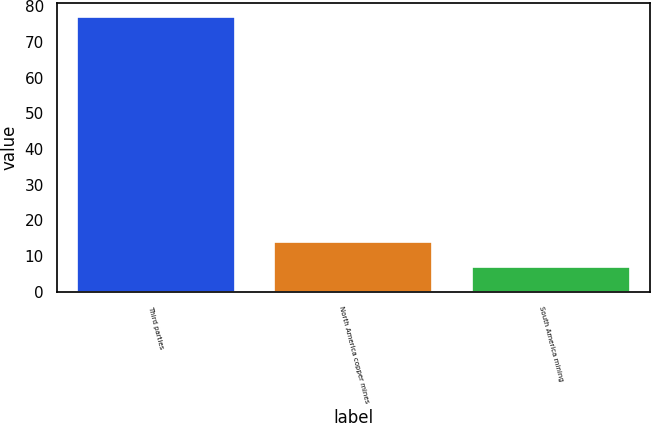Convert chart. <chart><loc_0><loc_0><loc_500><loc_500><bar_chart><fcel>Third parties<fcel>North America copper mines<fcel>South America mining<nl><fcel>77<fcel>14<fcel>7<nl></chart> 